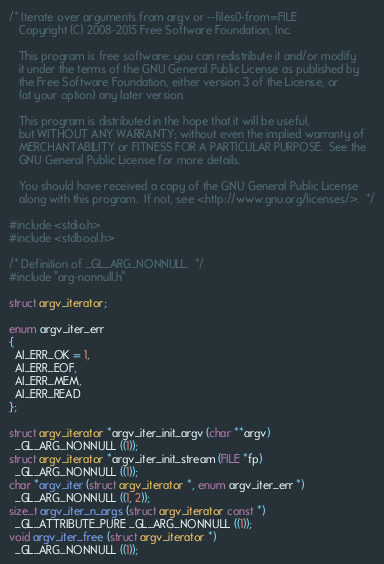<code> <loc_0><loc_0><loc_500><loc_500><_C_>/* Iterate over arguments from argv or --files0-from=FILE
   Copyright (C) 2008-2015 Free Software Foundation, Inc.

   This program is free software: you can redistribute it and/or modify
   it under the terms of the GNU General Public License as published by
   the Free Software Foundation, either version 3 of the License, or
   (at your option) any later version.

   This program is distributed in the hope that it will be useful,
   but WITHOUT ANY WARRANTY; without even the implied warranty of
   MERCHANTABILITY or FITNESS FOR A PARTICULAR PURPOSE.  See the
   GNU General Public License for more details.

   You should have received a copy of the GNU General Public License
   along with this program.  If not, see <http://www.gnu.org/licenses/>.  */

#include <stdio.h>
#include <stdbool.h>

/* Definition of _GL_ARG_NONNULL.  */
#include "arg-nonnull.h"

struct argv_iterator;

enum argv_iter_err
{
  AI_ERR_OK = 1,
  AI_ERR_EOF,
  AI_ERR_MEM,
  AI_ERR_READ
};

struct argv_iterator *argv_iter_init_argv (char **argv)
  _GL_ARG_NONNULL ((1));
struct argv_iterator *argv_iter_init_stream (FILE *fp)
  _GL_ARG_NONNULL ((1));
char *argv_iter (struct argv_iterator *, enum argv_iter_err *)
  _GL_ARG_NONNULL ((1, 2));
size_t argv_iter_n_args (struct argv_iterator const *)
  _GL_ATTRIBUTE_PURE _GL_ARG_NONNULL ((1));
void argv_iter_free (struct argv_iterator *)
  _GL_ARG_NONNULL ((1));
</code> 